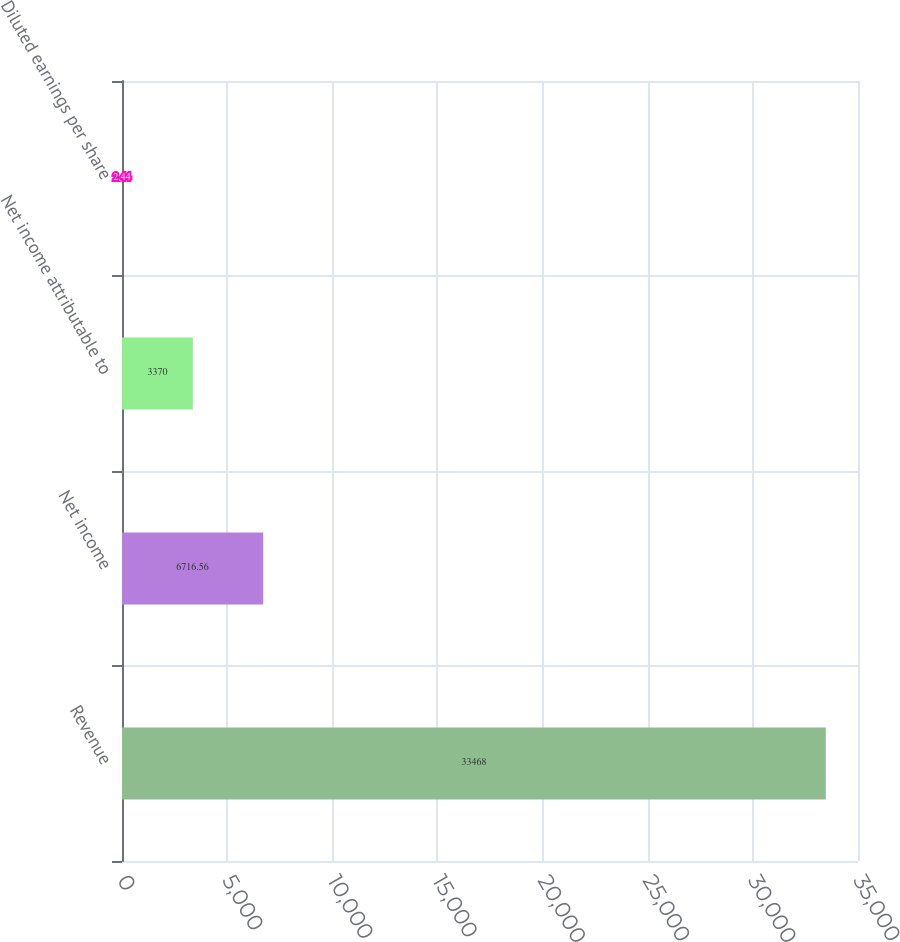Convert chart. <chart><loc_0><loc_0><loc_500><loc_500><bar_chart><fcel>Revenue<fcel>Net income<fcel>Net income attributable to<fcel>Diluted earnings per share<nl><fcel>33468<fcel>6716.56<fcel>3370<fcel>2.44<nl></chart> 